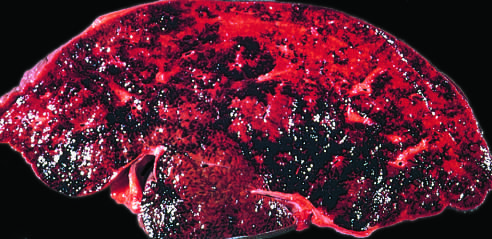what has caused severe hepatic congestion?
Answer the question using a single word or phrase. Thrombosis of the major veins 